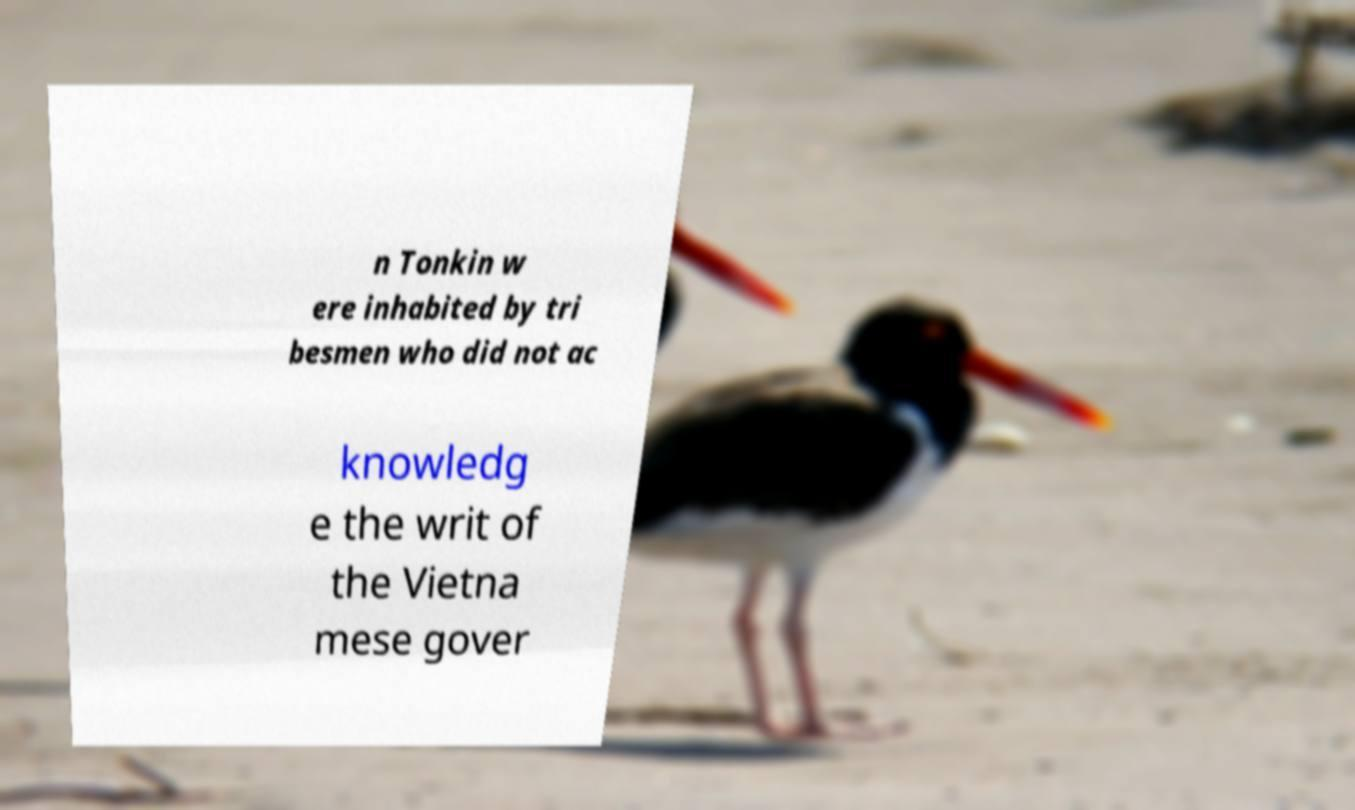What messages or text are displayed in this image? I need them in a readable, typed format. n Tonkin w ere inhabited by tri besmen who did not ac knowledg e the writ of the Vietna mese gover 